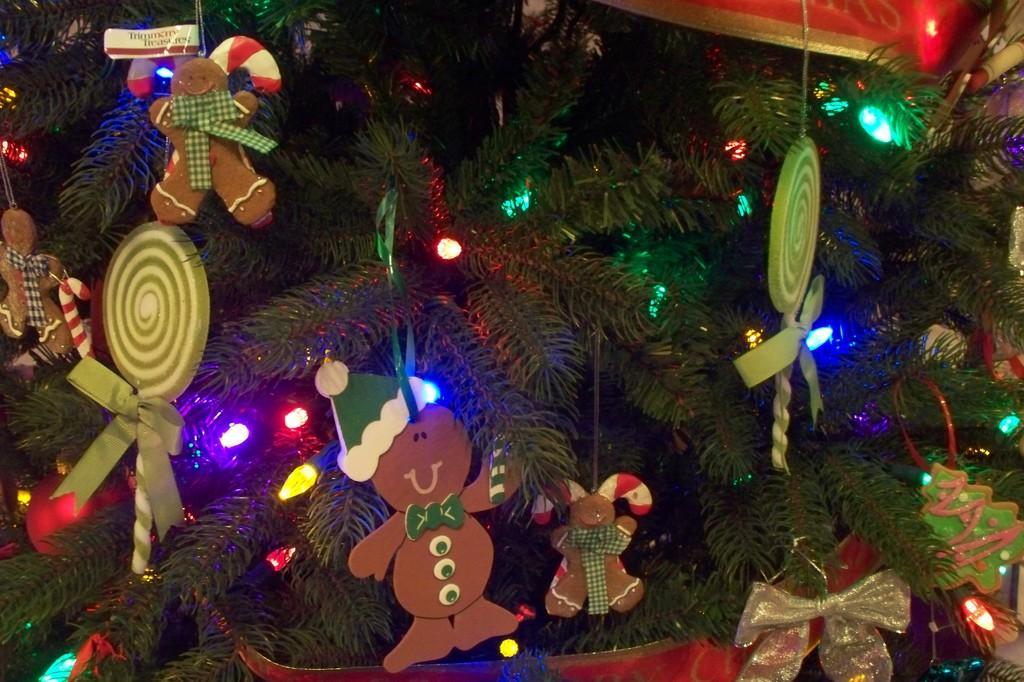Can you describe this image briefly? In this image we can see toys, lights and objects tied to a plant which is in a pot. 